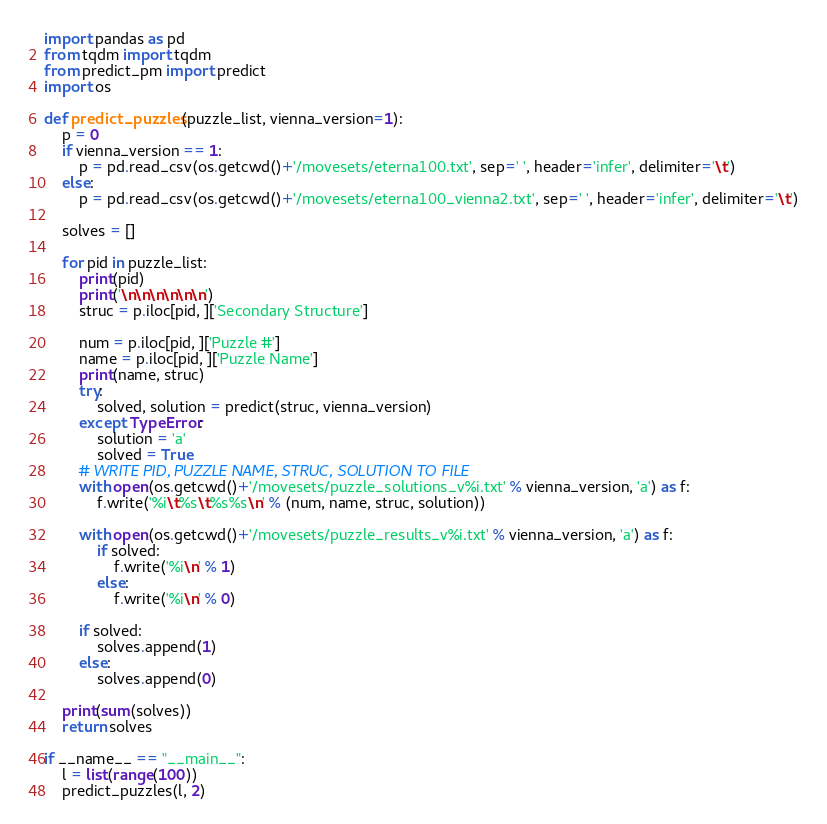Convert code to text. <code><loc_0><loc_0><loc_500><loc_500><_Python_>import pandas as pd
from tqdm import tqdm
from predict_pm import predict
import os

def predict_puzzles(puzzle_list, vienna_version=1):
    p = 0
    if vienna_version == 1:
        p = pd.read_csv(os.getcwd()+'/movesets/eterna100.txt', sep=' ', header='infer', delimiter='\t')
    else:
        p = pd.read_csv(os.getcwd()+'/movesets/eterna100_vienna2.txt', sep=' ', header='infer', delimiter='\t')

    solves = []

    for pid in puzzle_list:
        print(pid)
        print('\n\n\n\n\n\n')
        struc = p.iloc[pid, ]['Secondary Structure']
        
        num = p.iloc[pid, ]['Puzzle #']
        name = p.iloc[pid, ]['Puzzle Name']
        print(name, struc)
        try:
            solved, solution = predict(struc, vienna_version)
        except TypeError:
            solution = 'a'
            solved = True
        # WRITE PID, PUZZLE NAME, STRUC, SOLUTION TO FILE
        with open(os.getcwd()+'/movesets/puzzle_solutions_v%i.txt' % vienna_version, 'a') as f:
            f.write('%i\t%s\t%s%s\n' % (num, name, struc, solution))
        
        with open(os.getcwd()+'/movesets/puzzle_results_v%i.txt' % vienna_version, 'a') as f:
            if solved:
                f.write('%i\n' % 1)
            else:
                f.write('%i\n' % 0)

        if solved:
            solves.append(1)
        else:
            solves.append(0)
        
    print(sum(solves))
    return solves

if __name__ == "__main__":
    l = list(range(100))
    predict_puzzles(l, 2)
</code> 